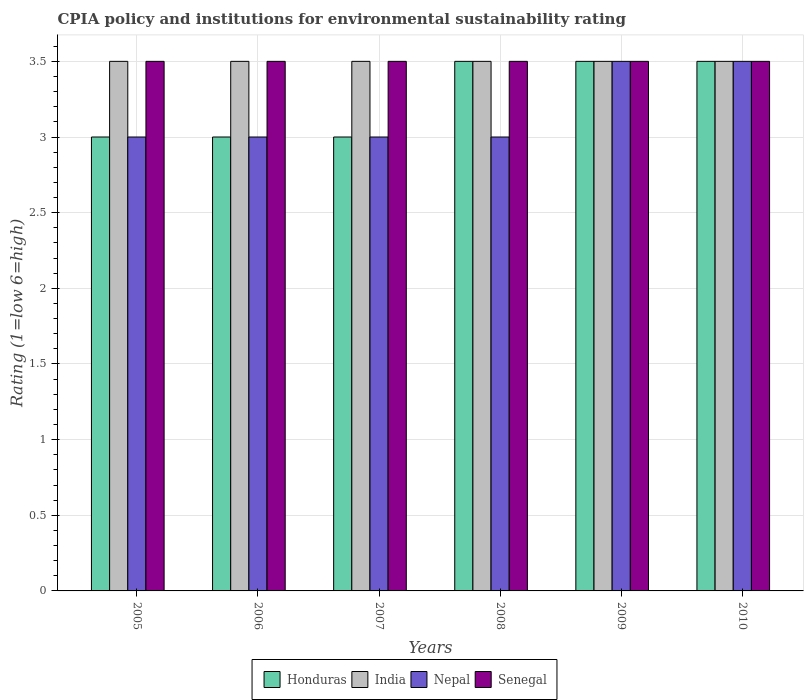How many groups of bars are there?
Your answer should be very brief. 6. Are the number of bars per tick equal to the number of legend labels?
Offer a very short reply. Yes. Are the number of bars on each tick of the X-axis equal?
Keep it short and to the point. Yes. How many bars are there on the 2nd tick from the right?
Ensure brevity in your answer.  4. In how many cases, is the number of bars for a given year not equal to the number of legend labels?
Your answer should be very brief. 0. In which year was the CPIA rating in Honduras maximum?
Give a very brief answer. 2008. What is the total CPIA rating in Senegal in the graph?
Your response must be concise. 21. What is the average CPIA rating in Honduras per year?
Provide a succinct answer. 3.25. What is the ratio of the CPIA rating in Nepal in 2005 to that in 2009?
Make the answer very short. 0.86. Is the difference between the CPIA rating in Nepal in 2007 and 2009 greater than the difference between the CPIA rating in India in 2007 and 2009?
Keep it short and to the point. No. What is the difference between the highest and the second highest CPIA rating in Nepal?
Provide a short and direct response. 0. What is the difference between the highest and the lowest CPIA rating in Senegal?
Offer a very short reply. 0. In how many years, is the CPIA rating in Honduras greater than the average CPIA rating in Honduras taken over all years?
Offer a terse response. 3. What does the 2nd bar from the right in 2010 represents?
Your response must be concise. Nepal. How many bars are there?
Your answer should be very brief. 24. Are all the bars in the graph horizontal?
Provide a short and direct response. No. How many years are there in the graph?
Make the answer very short. 6. What is the difference between two consecutive major ticks on the Y-axis?
Provide a short and direct response. 0.5. Where does the legend appear in the graph?
Give a very brief answer. Bottom center. What is the title of the graph?
Offer a terse response. CPIA policy and institutions for environmental sustainability rating. Does "Pacific island small states" appear as one of the legend labels in the graph?
Your response must be concise. No. What is the label or title of the Y-axis?
Give a very brief answer. Rating (1=low 6=high). What is the Rating (1=low 6=high) in Honduras in 2005?
Provide a short and direct response. 3. What is the Rating (1=low 6=high) in Nepal in 2005?
Ensure brevity in your answer.  3. What is the Rating (1=low 6=high) in India in 2007?
Offer a terse response. 3.5. What is the Rating (1=low 6=high) of Senegal in 2007?
Offer a very short reply. 3.5. What is the Rating (1=low 6=high) of Senegal in 2008?
Provide a short and direct response. 3.5. What is the Rating (1=low 6=high) in Honduras in 2009?
Your answer should be very brief. 3.5. What is the Rating (1=low 6=high) in India in 2010?
Provide a succinct answer. 3.5. What is the Rating (1=low 6=high) of Nepal in 2010?
Your response must be concise. 3.5. Across all years, what is the maximum Rating (1=low 6=high) in Honduras?
Keep it short and to the point. 3.5. Across all years, what is the maximum Rating (1=low 6=high) in Senegal?
Make the answer very short. 3.5. Across all years, what is the minimum Rating (1=low 6=high) of Honduras?
Make the answer very short. 3. What is the total Rating (1=low 6=high) in Honduras in the graph?
Your answer should be very brief. 19.5. What is the difference between the Rating (1=low 6=high) of India in 2005 and that in 2006?
Your response must be concise. 0. What is the difference between the Rating (1=low 6=high) of Senegal in 2005 and that in 2006?
Your answer should be compact. 0. What is the difference between the Rating (1=low 6=high) of Nepal in 2005 and that in 2007?
Ensure brevity in your answer.  0. What is the difference between the Rating (1=low 6=high) in Senegal in 2005 and that in 2007?
Offer a terse response. 0. What is the difference between the Rating (1=low 6=high) of Honduras in 2005 and that in 2008?
Give a very brief answer. -0.5. What is the difference between the Rating (1=low 6=high) of Nepal in 2005 and that in 2008?
Give a very brief answer. 0. What is the difference between the Rating (1=low 6=high) in India in 2005 and that in 2009?
Your answer should be compact. 0. What is the difference between the Rating (1=low 6=high) of Honduras in 2005 and that in 2010?
Give a very brief answer. -0.5. What is the difference between the Rating (1=low 6=high) of Nepal in 2005 and that in 2010?
Provide a short and direct response. -0.5. What is the difference between the Rating (1=low 6=high) of Senegal in 2005 and that in 2010?
Your response must be concise. 0. What is the difference between the Rating (1=low 6=high) in India in 2006 and that in 2007?
Your response must be concise. 0. What is the difference between the Rating (1=low 6=high) of Senegal in 2006 and that in 2007?
Keep it short and to the point. 0. What is the difference between the Rating (1=low 6=high) in Honduras in 2006 and that in 2008?
Your response must be concise. -0.5. What is the difference between the Rating (1=low 6=high) in India in 2006 and that in 2008?
Your answer should be very brief. 0. What is the difference between the Rating (1=low 6=high) in Senegal in 2006 and that in 2008?
Offer a very short reply. 0. What is the difference between the Rating (1=low 6=high) of Honduras in 2006 and that in 2010?
Your answer should be compact. -0.5. What is the difference between the Rating (1=low 6=high) of Nepal in 2006 and that in 2010?
Provide a short and direct response. -0.5. What is the difference between the Rating (1=low 6=high) in Senegal in 2006 and that in 2010?
Ensure brevity in your answer.  0. What is the difference between the Rating (1=low 6=high) of Honduras in 2007 and that in 2008?
Your response must be concise. -0.5. What is the difference between the Rating (1=low 6=high) of Senegal in 2007 and that in 2008?
Offer a terse response. 0. What is the difference between the Rating (1=low 6=high) in Honduras in 2007 and that in 2009?
Offer a terse response. -0.5. What is the difference between the Rating (1=low 6=high) in India in 2007 and that in 2009?
Your answer should be compact. 0. What is the difference between the Rating (1=low 6=high) in Senegal in 2007 and that in 2009?
Make the answer very short. 0. What is the difference between the Rating (1=low 6=high) in Nepal in 2007 and that in 2010?
Provide a succinct answer. -0.5. What is the difference between the Rating (1=low 6=high) of Honduras in 2008 and that in 2009?
Provide a short and direct response. 0. What is the difference between the Rating (1=low 6=high) in India in 2008 and that in 2009?
Offer a very short reply. 0. What is the difference between the Rating (1=low 6=high) of Senegal in 2008 and that in 2009?
Your answer should be very brief. 0. What is the difference between the Rating (1=low 6=high) of Honduras in 2008 and that in 2010?
Give a very brief answer. 0. What is the difference between the Rating (1=low 6=high) in India in 2008 and that in 2010?
Keep it short and to the point. 0. What is the difference between the Rating (1=low 6=high) in Nepal in 2008 and that in 2010?
Ensure brevity in your answer.  -0.5. What is the difference between the Rating (1=low 6=high) in Honduras in 2009 and that in 2010?
Your answer should be very brief. 0. What is the difference between the Rating (1=low 6=high) in Honduras in 2005 and the Rating (1=low 6=high) in Nepal in 2006?
Provide a succinct answer. 0. What is the difference between the Rating (1=low 6=high) in Honduras in 2005 and the Rating (1=low 6=high) in Senegal in 2006?
Ensure brevity in your answer.  -0.5. What is the difference between the Rating (1=low 6=high) in Nepal in 2005 and the Rating (1=low 6=high) in Senegal in 2006?
Your response must be concise. -0.5. What is the difference between the Rating (1=low 6=high) in Honduras in 2005 and the Rating (1=low 6=high) in India in 2007?
Give a very brief answer. -0.5. What is the difference between the Rating (1=low 6=high) in Honduras in 2005 and the Rating (1=low 6=high) in Nepal in 2007?
Your answer should be compact. 0. What is the difference between the Rating (1=low 6=high) of Honduras in 2005 and the Rating (1=low 6=high) of India in 2008?
Make the answer very short. -0.5. What is the difference between the Rating (1=low 6=high) in India in 2005 and the Rating (1=low 6=high) in Senegal in 2008?
Offer a terse response. 0. What is the difference between the Rating (1=low 6=high) of Honduras in 2005 and the Rating (1=low 6=high) of Nepal in 2009?
Keep it short and to the point. -0.5. What is the difference between the Rating (1=low 6=high) in India in 2005 and the Rating (1=low 6=high) in Senegal in 2009?
Ensure brevity in your answer.  0. What is the difference between the Rating (1=low 6=high) of Nepal in 2005 and the Rating (1=low 6=high) of Senegal in 2009?
Provide a succinct answer. -0.5. What is the difference between the Rating (1=low 6=high) of Honduras in 2005 and the Rating (1=low 6=high) of India in 2010?
Offer a terse response. -0.5. What is the difference between the Rating (1=low 6=high) in Honduras in 2005 and the Rating (1=low 6=high) in Nepal in 2010?
Provide a short and direct response. -0.5. What is the difference between the Rating (1=low 6=high) of Honduras in 2005 and the Rating (1=low 6=high) of Senegal in 2010?
Provide a succinct answer. -0.5. What is the difference between the Rating (1=low 6=high) of India in 2005 and the Rating (1=low 6=high) of Nepal in 2010?
Your response must be concise. 0. What is the difference between the Rating (1=low 6=high) in Nepal in 2005 and the Rating (1=low 6=high) in Senegal in 2010?
Provide a succinct answer. -0.5. What is the difference between the Rating (1=low 6=high) of Honduras in 2006 and the Rating (1=low 6=high) of Senegal in 2007?
Your response must be concise. -0.5. What is the difference between the Rating (1=low 6=high) in India in 2006 and the Rating (1=low 6=high) in Senegal in 2007?
Your response must be concise. 0. What is the difference between the Rating (1=low 6=high) of Nepal in 2006 and the Rating (1=low 6=high) of Senegal in 2008?
Provide a succinct answer. -0.5. What is the difference between the Rating (1=low 6=high) of Honduras in 2006 and the Rating (1=low 6=high) of India in 2009?
Keep it short and to the point. -0.5. What is the difference between the Rating (1=low 6=high) of India in 2006 and the Rating (1=low 6=high) of Senegal in 2009?
Your response must be concise. 0. What is the difference between the Rating (1=low 6=high) in Nepal in 2006 and the Rating (1=low 6=high) in Senegal in 2009?
Provide a short and direct response. -0.5. What is the difference between the Rating (1=low 6=high) of Honduras in 2006 and the Rating (1=low 6=high) of India in 2010?
Your answer should be compact. -0.5. What is the difference between the Rating (1=low 6=high) in India in 2006 and the Rating (1=low 6=high) in Nepal in 2010?
Ensure brevity in your answer.  0. What is the difference between the Rating (1=low 6=high) in India in 2006 and the Rating (1=low 6=high) in Senegal in 2010?
Your answer should be very brief. 0. What is the difference between the Rating (1=low 6=high) in Nepal in 2006 and the Rating (1=low 6=high) in Senegal in 2010?
Ensure brevity in your answer.  -0.5. What is the difference between the Rating (1=low 6=high) of Honduras in 2007 and the Rating (1=low 6=high) of Senegal in 2008?
Your answer should be compact. -0.5. What is the difference between the Rating (1=low 6=high) in India in 2007 and the Rating (1=low 6=high) in Nepal in 2008?
Make the answer very short. 0.5. What is the difference between the Rating (1=low 6=high) of Nepal in 2007 and the Rating (1=low 6=high) of Senegal in 2008?
Your answer should be very brief. -0.5. What is the difference between the Rating (1=low 6=high) in Honduras in 2007 and the Rating (1=low 6=high) in India in 2009?
Provide a succinct answer. -0.5. What is the difference between the Rating (1=low 6=high) in Honduras in 2007 and the Rating (1=low 6=high) in Nepal in 2009?
Your answer should be compact. -0.5. What is the difference between the Rating (1=low 6=high) of Honduras in 2007 and the Rating (1=low 6=high) of Senegal in 2009?
Offer a terse response. -0.5. What is the difference between the Rating (1=low 6=high) of India in 2007 and the Rating (1=low 6=high) of Senegal in 2009?
Ensure brevity in your answer.  0. What is the difference between the Rating (1=low 6=high) in Nepal in 2007 and the Rating (1=low 6=high) in Senegal in 2009?
Offer a terse response. -0.5. What is the difference between the Rating (1=low 6=high) of Honduras in 2007 and the Rating (1=low 6=high) of India in 2010?
Your answer should be very brief. -0.5. What is the difference between the Rating (1=low 6=high) in Honduras in 2007 and the Rating (1=low 6=high) in Nepal in 2010?
Provide a succinct answer. -0.5. What is the difference between the Rating (1=low 6=high) of Honduras in 2007 and the Rating (1=low 6=high) of Senegal in 2010?
Your response must be concise. -0.5. What is the difference between the Rating (1=low 6=high) of India in 2007 and the Rating (1=low 6=high) of Senegal in 2010?
Your answer should be very brief. 0. What is the difference between the Rating (1=low 6=high) of Nepal in 2007 and the Rating (1=low 6=high) of Senegal in 2010?
Keep it short and to the point. -0.5. What is the difference between the Rating (1=low 6=high) in India in 2008 and the Rating (1=low 6=high) in Nepal in 2009?
Provide a succinct answer. 0. What is the difference between the Rating (1=low 6=high) in India in 2008 and the Rating (1=low 6=high) in Senegal in 2009?
Offer a very short reply. 0. What is the difference between the Rating (1=low 6=high) of India in 2008 and the Rating (1=low 6=high) of Nepal in 2010?
Your answer should be very brief. 0. What is the difference between the Rating (1=low 6=high) in Honduras in 2009 and the Rating (1=low 6=high) in India in 2010?
Provide a short and direct response. 0. What is the difference between the Rating (1=low 6=high) of Honduras in 2009 and the Rating (1=low 6=high) of Nepal in 2010?
Provide a short and direct response. 0. What is the difference between the Rating (1=low 6=high) in Honduras in 2009 and the Rating (1=low 6=high) in Senegal in 2010?
Offer a terse response. 0. What is the difference between the Rating (1=low 6=high) of India in 2009 and the Rating (1=low 6=high) of Nepal in 2010?
Give a very brief answer. 0. What is the average Rating (1=low 6=high) of Honduras per year?
Offer a very short reply. 3.25. What is the average Rating (1=low 6=high) of India per year?
Your response must be concise. 3.5. What is the average Rating (1=low 6=high) in Nepal per year?
Offer a very short reply. 3.17. What is the average Rating (1=low 6=high) in Senegal per year?
Your answer should be very brief. 3.5. In the year 2005, what is the difference between the Rating (1=low 6=high) in Honduras and Rating (1=low 6=high) in India?
Your answer should be compact. -0.5. In the year 2005, what is the difference between the Rating (1=low 6=high) in Honduras and Rating (1=low 6=high) in Nepal?
Your answer should be compact. 0. In the year 2005, what is the difference between the Rating (1=low 6=high) in Honduras and Rating (1=low 6=high) in Senegal?
Offer a terse response. -0.5. In the year 2005, what is the difference between the Rating (1=low 6=high) in India and Rating (1=low 6=high) in Senegal?
Provide a short and direct response. 0. In the year 2005, what is the difference between the Rating (1=low 6=high) of Nepal and Rating (1=low 6=high) of Senegal?
Your answer should be compact. -0.5. In the year 2006, what is the difference between the Rating (1=low 6=high) of Honduras and Rating (1=low 6=high) of Nepal?
Make the answer very short. 0. In the year 2006, what is the difference between the Rating (1=low 6=high) in India and Rating (1=low 6=high) in Nepal?
Give a very brief answer. 0.5. In the year 2006, what is the difference between the Rating (1=low 6=high) in India and Rating (1=low 6=high) in Senegal?
Offer a terse response. 0. In the year 2006, what is the difference between the Rating (1=low 6=high) in Nepal and Rating (1=low 6=high) in Senegal?
Your answer should be very brief. -0.5. In the year 2007, what is the difference between the Rating (1=low 6=high) of Honduras and Rating (1=low 6=high) of Senegal?
Ensure brevity in your answer.  -0.5. In the year 2007, what is the difference between the Rating (1=low 6=high) in India and Rating (1=low 6=high) in Nepal?
Give a very brief answer. 0.5. In the year 2007, what is the difference between the Rating (1=low 6=high) of India and Rating (1=low 6=high) of Senegal?
Keep it short and to the point. 0. In the year 2007, what is the difference between the Rating (1=low 6=high) in Nepal and Rating (1=low 6=high) in Senegal?
Provide a short and direct response. -0.5. In the year 2008, what is the difference between the Rating (1=low 6=high) of Honduras and Rating (1=low 6=high) of Nepal?
Make the answer very short. 0.5. In the year 2008, what is the difference between the Rating (1=low 6=high) in Honduras and Rating (1=low 6=high) in Senegal?
Provide a succinct answer. 0. In the year 2008, what is the difference between the Rating (1=low 6=high) in India and Rating (1=low 6=high) in Nepal?
Make the answer very short. 0.5. In the year 2008, what is the difference between the Rating (1=low 6=high) of Nepal and Rating (1=low 6=high) of Senegal?
Provide a short and direct response. -0.5. In the year 2009, what is the difference between the Rating (1=low 6=high) of Nepal and Rating (1=low 6=high) of Senegal?
Offer a terse response. 0. In the year 2010, what is the difference between the Rating (1=low 6=high) in Honduras and Rating (1=low 6=high) in India?
Keep it short and to the point. 0. In the year 2010, what is the difference between the Rating (1=low 6=high) of Honduras and Rating (1=low 6=high) of Nepal?
Make the answer very short. 0. In the year 2010, what is the difference between the Rating (1=low 6=high) in Honduras and Rating (1=low 6=high) in Senegal?
Your answer should be compact. 0. In the year 2010, what is the difference between the Rating (1=low 6=high) in Nepal and Rating (1=low 6=high) in Senegal?
Offer a very short reply. 0. What is the ratio of the Rating (1=low 6=high) of Honduras in 2005 to that in 2006?
Keep it short and to the point. 1. What is the ratio of the Rating (1=low 6=high) of Nepal in 2005 to that in 2006?
Your response must be concise. 1. What is the ratio of the Rating (1=low 6=high) of Senegal in 2005 to that in 2006?
Your response must be concise. 1. What is the ratio of the Rating (1=low 6=high) in Honduras in 2005 to that in 2007?
Your answer should be very brief. 1. What is the ratio of the Rating (1=low 6=high) in India in 2005 to that in 2007?
Offer a very short reply. 1. What is the ratio of the Rating (1=low 6=high) in Honduras in 2005 to that in 2008?
Your answer should be very brief. 0.86. What is the ratio of the Rating (1=low 6=high) in Senegal in 2005 to that in 2008?
Offer a terse response. 1. What is the ratio of the Rating (1=low 6=high) of India in 2005 to that in 2009?
Give a very brief answer. 1. What is the ratio of the Rating (1=low 6=high) of Senegal in 2005 to that in 2009?
Offer a terse response. 1. What is the ratio of the Rating (1=low 6=high) in India in 2005 to that in 2010?
Offer a very short reply. 1. What is the ratio of the Rating (1=low 6=high) of Nepal in 2005 to that in 2010?
Offer a very short reply. 0.86. What is the ratio of the Rating (1=low 6=high) of Senegal in 2005 to that in 2010?
Your answer should be very brief. 1. What is the ratio of the Rating (1=low 6=high) in Honduras in 2006 to that in 2007?
Your answer should be compact. 1. What is the ratio of the Rating (1=low 6=high) of India in 2006 to that in 2007?
Give a very brief answer. 1. What is the ratio of the Rating (1=low 6=high) in Nepal in 2006 to that in 2007?
Offer a terse response. 1. What is the ratio of the Rating (1=low 6=high) in Senegal in 2006 to that in 2007?
Provide a succinct answer. 1. What is the ratio of the Rating (1=low 6=high) in Honduras in 2006 to that in 2008?
Provide a succinct answer. 0.86. What is the ratio of the Rating (1=low 6=high) in India in 2006 to that in 2008?
Provide a short and direct response. 1. What is the ratio of the Rating (1=low 6=high) of Nepal in 2006 to that in 2008?
Keep it short and to the point. 1. What is the ratio of the Rating (1=low 6=high) in Senegal in 2006 to that in 2008?
Keep it short and to the point. 1. What is the ratio of the Rating (1=low 6=high) of Honduras in 2006 to that in 2009?
Offer a very short reply. 0.86. What is the ratio of the Rating (1=low 6=high) of Senegal in 2006 to that in 2009?
Offer a terse response. 1. What is the ratio of the Rating (1=low 6=high) in Honduras in 2006 to that in 2010?
Ensure brevity in your answer.  0.86. What is the ratio of the Rating (1=low 6=high) of India in 2006 to that in 2010?
Offer a very short reply. 1. What is the ratio of the Rating (1=low 6=high) of Nepal in 2006 to that in 2010?
Make the answer very short. 0.86. What is the ratio of the Rating (1=low 6=high) of India in 2007 to that in 2008?
Offer a very short reply. 1. What is the ratio of the Rating (1=low 6=high) of Nepal in 2007 to that in 2008?
Your response must be concise. 1. What is the ratio of the Rating (1=low 6=high) of Senegal in 2007 to that in 2008?
Your answer should be compact. 1. What is the ratio of the Rating (1=low 6=high) in Honduras in 2007 to that in 2009?
Make the answer very short. 0.86. What is the ratio of the Rating (1=low 6=high) in India in 2007 to that in 2009?
Your answer should be compact. 1. What is the ratio of the Rating (1=low 6=high) in Nepal in 2007 to that in 2009?
Make the answer very short. 0.86. What is the ratio of the Rating (1=low 6=high) in Honduras in 2007 to that in 2010?
Make the answer very short. 0.86. What is the ratio of the Rating (1=low 6=high) in Honduras in 2008 to that in 2009?
Provide a short and direct response. 1. What is the ratio of the Rating (1=low 6=high) of Nepal in 2008 to that in 2009?
Your response must be concise. 0.86. What is the ratio of the Rating (1=low 6=high) in Senegal in 2008 to that in 2009?
Ensure brevity in your answer.  1. What is the ratio of the Rating (1=low 6=high) of Honduras in 2009 to that in 2010?
Offer a very short reply. 1. What is the ratio of the Rating (1=low 6=high) in India in 2009 to that in 2010?
Your answer should be compact. 1. What is the ratio of the Rating (1=low 6=high) in Nepal in 2009 to that in 2010?
Offer a terse response. 1. What is the ratio of the Rating (1=low 6=high) of Senegal in 2009 to that in 2010?
Ensure brevity in your answer.  1. What is the difference between the highest and the second highest Rating (1=low 6=high) of Senegal?
Your response must be concise. 0. What is the difference between the highest and the lowest Rating (1=low 6=high) in Honduras?
Your answer should be very brief. 0.5. What is the difference between the highest and the lowest Rating (1=low 6=high) of India?
Make the answer very short. 0. What is the difference between the highest and the lowest Rating (1=low 6=high) of Senegal?
Keep it short and to the point. 0. 